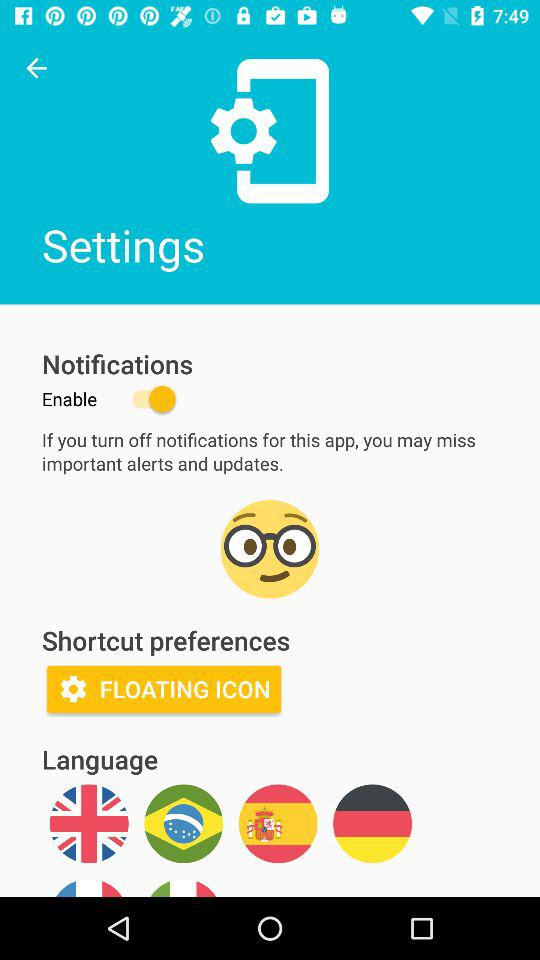What is the setting for "Shortcut preferences"? The setting is "FLOATING ICON". 